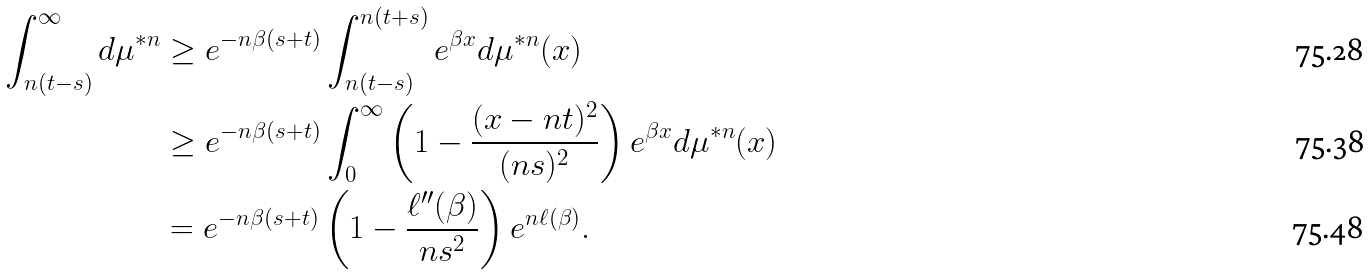<formula> <loc_0><loc_0><loc_500><loc_500>\int _ { n ( t - s ) } ^ { \infty } d \mu ^ { * n } & \geq e ^ { - n \beta ( s + t ) } \int _ { n ( t - s ) } ^ { n ( t + s ) } e ^ { \beta x } d \mu ^ { * n } ( x ) \\ & \geq e ^ { - n \beta ( s + t ) } \int _ { 0 } ^ { \infty } \left ( 1 - \frac { ( x - n t ) ^ { 2 } } { ( n s ) ^ { 2 } } \right ) e ^ { \beta x } d \mu ^ { * n } ( x ) \\ & = e ^ { - n \beta ( s + t ) } \left ( 1 - \frac { \ell ^ { \prime \prime } ( \beta ) } { n s ^ { 2 } } \right ) e ^ { n \ell ( \beta ) } .</formula> 